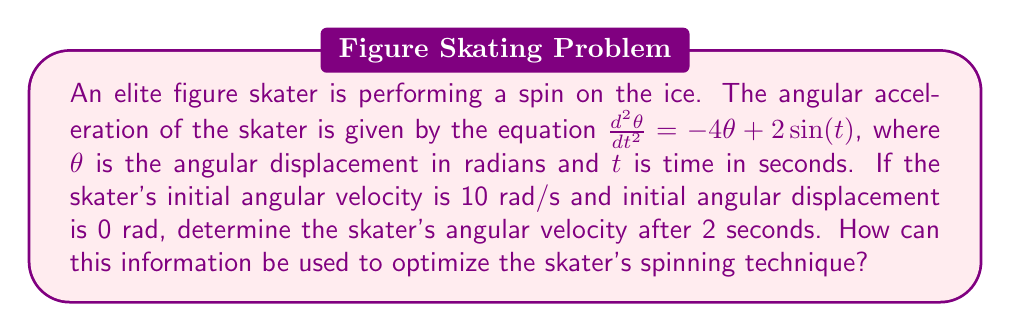Can you answer this question? To solve this problem, we need to use the theory of second-order linear differential equations.

1) The given equation is: $\frac{d^2\theta}{dt^2} = -4\theta + 2\sin(t)$

2) This is a non-homogeneous second-order linear differential equation. The general solution will be the sum of the complementary function (solution to the homogeneous equation) and a particular integral.

3) The complementary function:
   The characteristic equation is $r^2 + 4 = 0$
   Solving this: $r = \pm 2i$
   Therefore, the complementary function is: $\theta_c = A\cos(2t) + B\sin(2t)$

4) A particular integral:
   We can use the method of undetermined coefficients. Let's assume a particular solution of the form:
   $\theta_p = C\sin(t) + D\cos(t)$
   
   Substituting this into the original equation and equating coefficients, we get:
   $C = \frac{2}{5}$ and $D = 0$

   So, $\theta_p = \frac{2}{5}\sin(t)$

5) The general solution is:
   $\theta = A\cos(2t) + B\sin(2t) + \frac{2}{5}\sin(t)$

6) To find A and B, we use the initial conditions:
   At $t=0$, $\theta = 0$ and $\frac{d\theta}{dt} = 10$

   This gives us:
   $A = 0$ and $B = 5$

7) Therefore, the particular solution is:
   $\theta = 5\sin(2t) + \frac{2}{5}\sin(t)$

8) To find the angular velocity at $t=2$, we differentiate $\theta$ with respect to $t$:
   $\frac{d\theta}{dt} = 10\cos(2t) + \frac{2}{5}\cos(t)$

9) Evaluating this at $t=2$:
   $\frac{d\theta}{dt}|_{t=2} = 10\cos(4) + \frac{2}{5}\cos(2) \approx -5.13$ rad/s

This information can be used to optimize the skater's spinning technique by understanding how the angular velocity changes over time. The coach can use this to determine the optimal duration for spins and when to transition between different spinning positions to maintain the desired angular velocity.
Answer: The skater's angular velocity after 2 seconds is approximately -5.13 rad/s. 